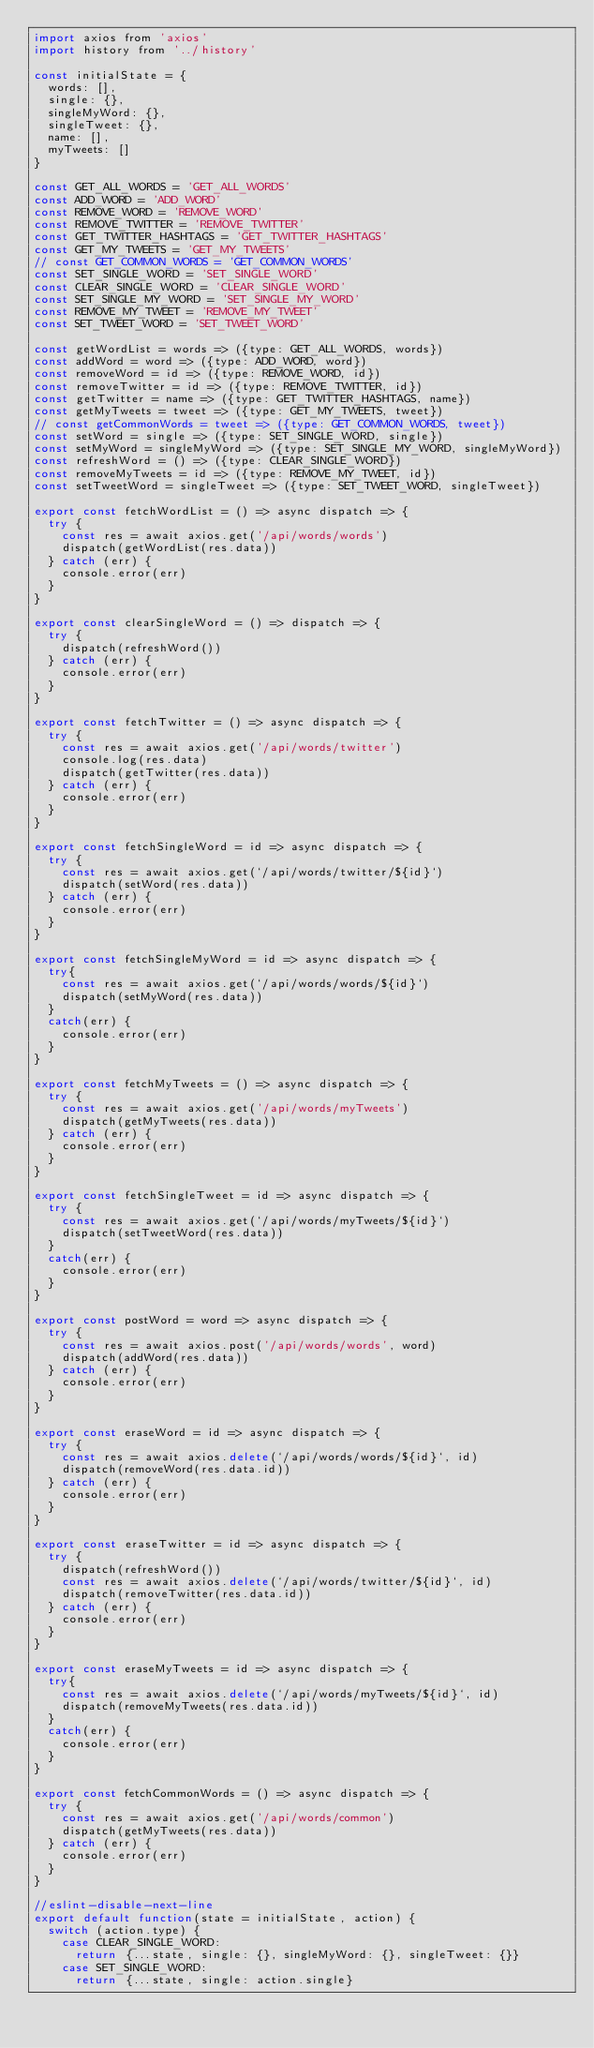<code> <loc_0><loc_0><loc_500><loc_500><_JavaScript_>import axios from 'axios'
import history from '../history'

const initialState = {
  words: [],
  single: {},
  singleMyWord: {},
  singleTweet: {},
  name: [],
  myTweets: []
}

const GET_ALL_WORDS = 'GET_ALL_WORDS'
const ADD_WORD = 'ADD_WORD'
const REMOVE_WORD = 'REMOVE_WORD'
const REMOVE_TWITTER = 'REMOVE_TWITTER'
const GET_TWITTER_HASHTAGS = 'GET_TWITTER_HASHTAGS'
const GET_MY_TWEETS = 'GET_MY_TWEETS'
// const GET_COMMON_WORDS = 'GET_COMMON_WORDS'
const SET_SINGLE_WORD = 'SET_SINGLE_WORD'
const CLEAR_SINGLE_WORD = 'CLEAR_SINGLE_WORD'
const SET_SINGLE_MY_WORD = 'SET_SINGLE_MY_WORD'
const REMOVE_MY_TWEET = 'REMOVE_MY_TWEET'
const SET_TWEET_WORD = 'SET_TWEET_WORD'

const getWordList = words => ({type: GET_ALL_WORDS, words})
const addWord = word => ({type: ADD_WORD, word})
const removeWord = id => ({type: REMOVE_WORD, id})
const removeTwitter = id => ({type: REMOVE_TWITTER, id})
const getTwitter = name => ({type: GET_TWITTER_HASHTAGS, name})
const getMyTweets = tweet => ({type: GET_MY_TWEETS, tweet})
// const getCommonWords = tweet => ({type: GET_COMMON_WORDS, tweet})
const setWord = single => ({type: SET_SINGLE_WORD, single})
const setMyWord = singleMyWord => ({type: SET_SINGLE_MY_WORD, singleMyWord})
const refreshWord = () => ({type: CLEAR_SINGLE_WORD})
const removeMyTweets = id => ({type: REMOVE_MY_TWEET, id})
const setTweetWord = singleTweet => ({type: SET_TWEET_WORD, singleTweet})

export const fetchWordList = () => async dispatch => {
  try {
    const res = await axios.get('/api/words/words')
    dispatch(getWordList(res.data))
  } catch (err) {
    console.error(err)
  }
}

export const clearSingleWord = () => dispatch => {
  try {
    dispatch(refreshWord())
  } catch (err) {
    console.error(err)
  }
}

export const fetchTwitter = () => async dispatch => {
  try {
    const res = await axios.get('/api/words/twitter')
    console.log(res.data)
    dispatch(getTwitter(res.data))
  } catch (err) {
    console.error(err)
  }
}

export const fetchSingleWord = id => async dispatch => {
  try {
    const res = await axios.get(`/api/words/twitter/${id}`)
    dispatch(setWord(res.data))
  } catch (err) {
    console.error(err)
  }
}

export const fetchSingleMyWord = id => async dispatch => {
  try{
    const res = await axios.get(`/api/words/words/${id}`)
    dispatch(setMyWord(res.data))
  }
  catch(err) {
    console.error(err)
  }
}

export const fetchMyTweets = () => async dispatch => {
  try {
    const res = await axios.get('/api/words/myTweets')
    dispatch(getMyTweets(res.data))
  } catch (err) {
    console.error(err)
  }
}

export const fetchSingleTweet = id => async dispatch => {
  try {
    const res = await axios.get(`/api/words/myTweets/${id}`)
    dispatch(setTweetWord(res.data))
  }
  catch(err) {
    console.error(err)
  }
}

export const postWord = word => async dispatch => {
  try {
    const res = await axios.post('/api/words/words', word)
    dispatch(addWord(res.data))
  } catch (err) {
    console.error(err)
  }
}

export const eraseWord = id => async dispatch => {
  try {
    const res = await axios.delete(`/api/words/words/${id}`, id)
    dispatch(removeWord(res.data.id))
  } catch (err) {
    console.error(err)
  }
}

export const eraseTwitter = id => async dispatch => {
  try {
    dispatch(refreshWord())
    const res = await axios.delete(`/api/words/twitter/${id}`, id)
    dispatch(removeTwitter(res.data.id))
  } catch (err) {
    console.error(err)
  }
}

export const eraseMyTweets = id => async dispatch => {
  try{
    const res = await axios.delete(`/api/words/myTweets/${id}`, id)
    dispatch(removeMyTweets(res.data.id))
  }
  catch(err) {
    console.error(err)
  }
}

export const fetchCommonWords = () => async dispatch => {
  try {
    const res = await axios.get('/api/words/common')
    dispatch(getMyTweets(res.data))
  } catch (err) {
    console.error(err)
  }
}

//eslint-disable-next-line
export default function(state = initialState, action) {
  switch (action.type) {
    case CLEAR_SINGLE_WORD:
      return {...state, single: {}, singleMyWord: {}, singleTweet: {}}
    case SET_SINGLE_WORD:
      return {...state, single: action.single}</code> 